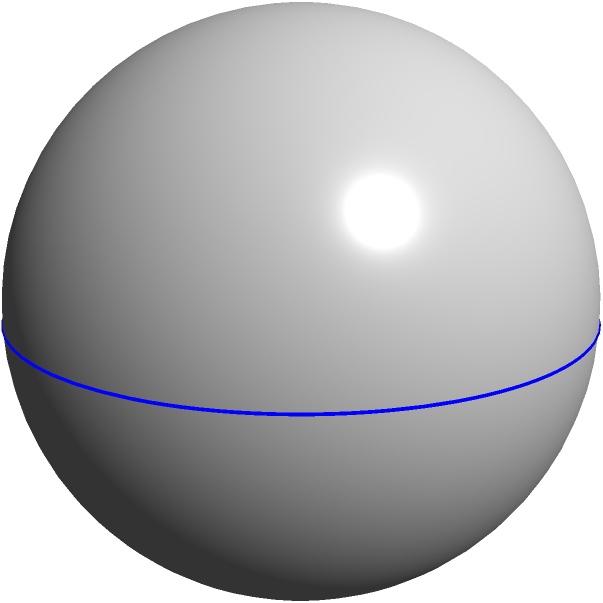As the head of a bowling equipment manufacturing company, you're developing a new line of premium bowling balls. Given that the radius of a standard bowling ball is 4.25 inches, calculate the volume of the ball to determine the amount of material needed for production. Round your answer to the nearest cubic inch. To calculate the volume of a bowling ball, we need to use the formula for the volume of a sphere:

$$V = \frac{4}{3}\pi r^3$$

Where:
$V$ is the volume
$r$ is the radius

Let's plug in the given radius:

$$V = \frac{4}{3}\pi (4.25)^3$$

Step 1: Calculate $r^3$
$$(4.25)^3 = 76.765625$$

Step 2: Multiply by $\frac{4}{3}$
$$\frac{4}{3} \times 76.765625 = 102.35416667$$

Step 3: Multiply by $\pi$
$$102.35416667 \times \pi \approx 321.53$$

Step 4: Round to the nearest cubic inch
$$321.53 \approx 322$$

Therefore, the volume of the bowling ball is approximately 322 cubic inches.
Answer: 322 cubic inches 